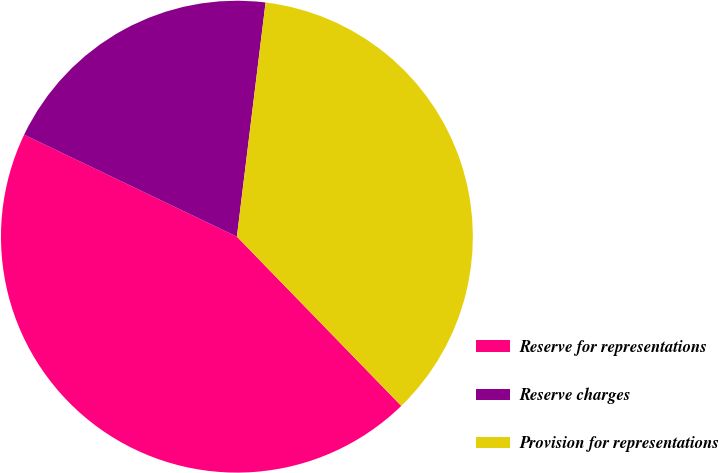<chart> <loc_0><loc_0><loc_500><loc_500><pie_chart><fcel>Reserve for representations<fcel>Reserve charges<fcel>Provision for representations<nl><fcel>44.38%<fcel>19.83%<fcel>35.79%<nl></chart> 